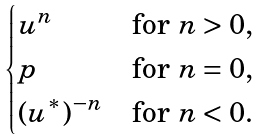Convert formula to latex. <formula><loc_0><loc_0><loc_500><loc_500>\begin{cases} u ^ { n } & \text {for $n>0$,} \\ p & \text {for $n=0$,} \\ ( u ^ { * } ) ^ { - n } & \text {for $n<0$.} \\ \end{cases}</formula> 